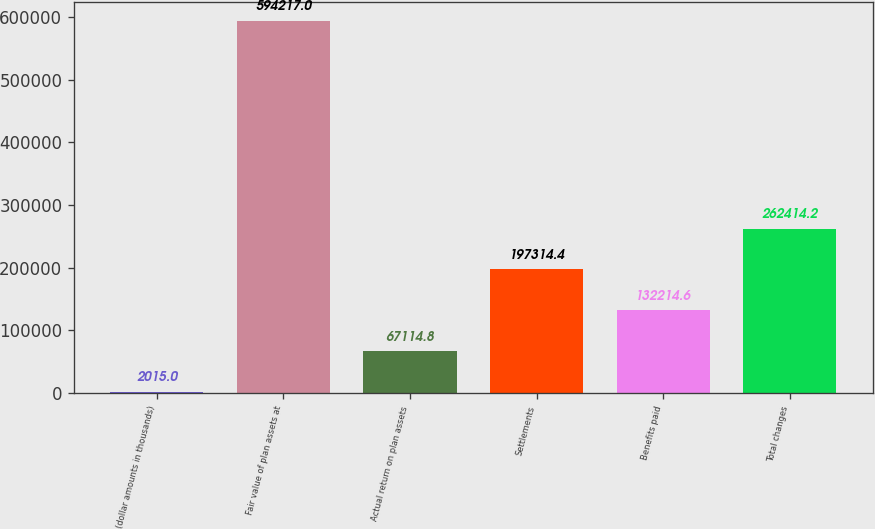<chart> <loc_0><loc_0><loc_500><loc_500><bar_chart><fcel>(dollar amounts in thousands)<fcel>Fair value of plan assets at<fcel>Actual return on plan assets<fcel>Settlements<fcel>Benefits paid<fcel>Total changes<nl><fcel>2015<fcel>594217<fcel>67114.8<fcel>197314<fcel>132215<fcel>262414<nl></chart> 